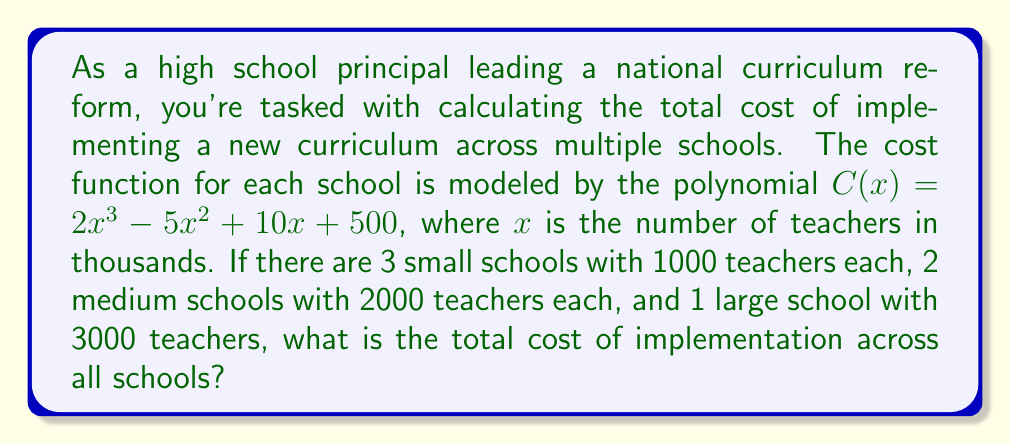Give your solution to this math problem. Let's approach this step-by-step:

1) First, we need to evaluate the cost function for each school size:

   For small schools (1000 teachers = 1 in thousands):
   $C(1) = 2(1)^3 - 5(1)^2 + 10(1) + 500 = 2 - 5 + 10 + 500 = 507$ thousand dollars

   For medium schools (2000 teachers = 2 in thousands):
   $C(2) = 2(2)^3 - 5(2)^2 + 10(2) + 500 = 16 - 20 + 20 + 500 = 516$ thousand dollars

   For large school (3000 teachers = 3 in thousands):
   $C(3) = 2(3)^3 - 5(3)^2 + 10(3) + 500 = 54 - 45 + 30 + 500 = 539$ thousand dollars

2) Now, we need to multiply each cost by the number of schools of that size:

   Small schools: $507 \times 3 = 1521$ thousand dollars
   Medium schools: $516 \times 2 = 1032$ thousand dollars
   Large school: $539 \times 1 = 539$ thousand dollars

3) Finally, we sum up all these costs:

   Total cost = $1521 + 1032 + 539 = 3092$ thousand dollars
Answer: The total cost of implementing the new curriculum across all schools is $3,092,000. 